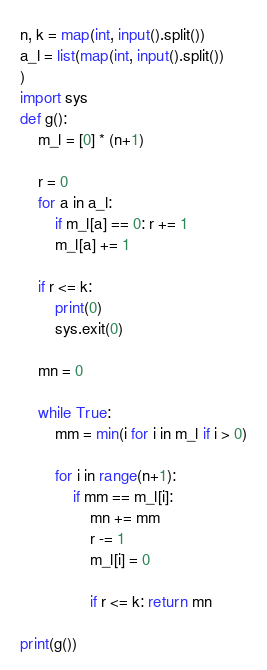<code> <loc_0><loc_0><loc_500><loc_500><_Python_>n, k = map(int, input().split())
a_l = list(map(int, input().split())
)
import sys
def g():
    m_l = [0] * (n+1)

    r = 0
    for a in a_l:
        if m_l[a] == 0: r += 1
        m_l[a] += 1

    if r <= k:
        print(0)
        sys.exit(0)

    mn = 0
    
    while True:
        mm = min(i for i in m_l if i > 0)

        for i in range(n+1):
            if mm == m_l[i]:
                mn += mm
                r -= 1
                m_l[i] = 0

                if r <= k: return mn
        
print(g())
</code> 